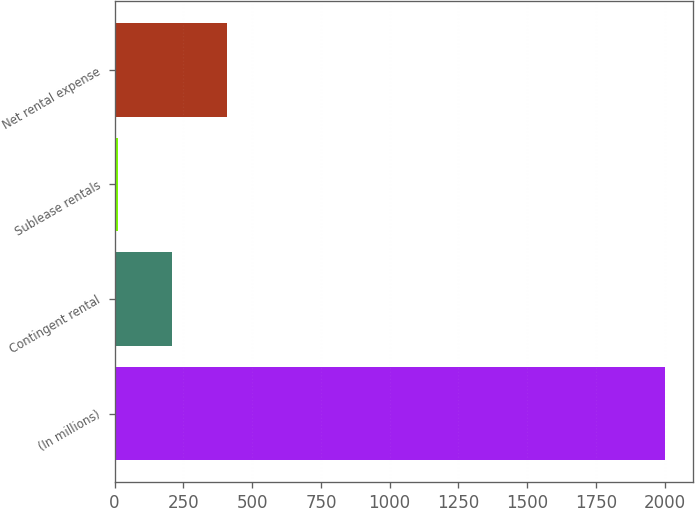Convert chart to OTSL. <chart><loc_0><loc_0><loc_500><loc_500><bar_chart><fcel>(In millions)<fcel>Contingent rental<fcel>Sublease rentals<fcel>Net rental expense<nl><fcel>2002<fcel>210.1<fcel>11<fcel>409.2<nl></chart> 